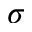Convert formula to latex. <formula><loc_0><loc_0><loc_500><loc_500>\sigma</formula> 